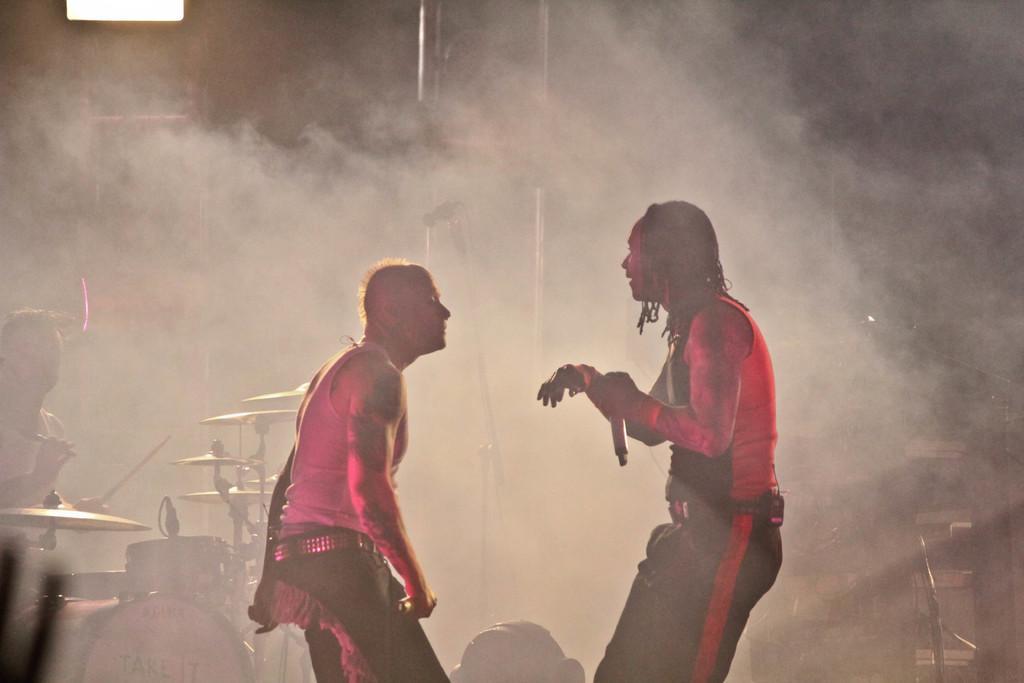Describe this image in one or two sentences. In this picture we can see two men holding the microphones. On the left side of the image, there is another man holding an object. Behind the men, there are musical instruments, smoke and some objects. 